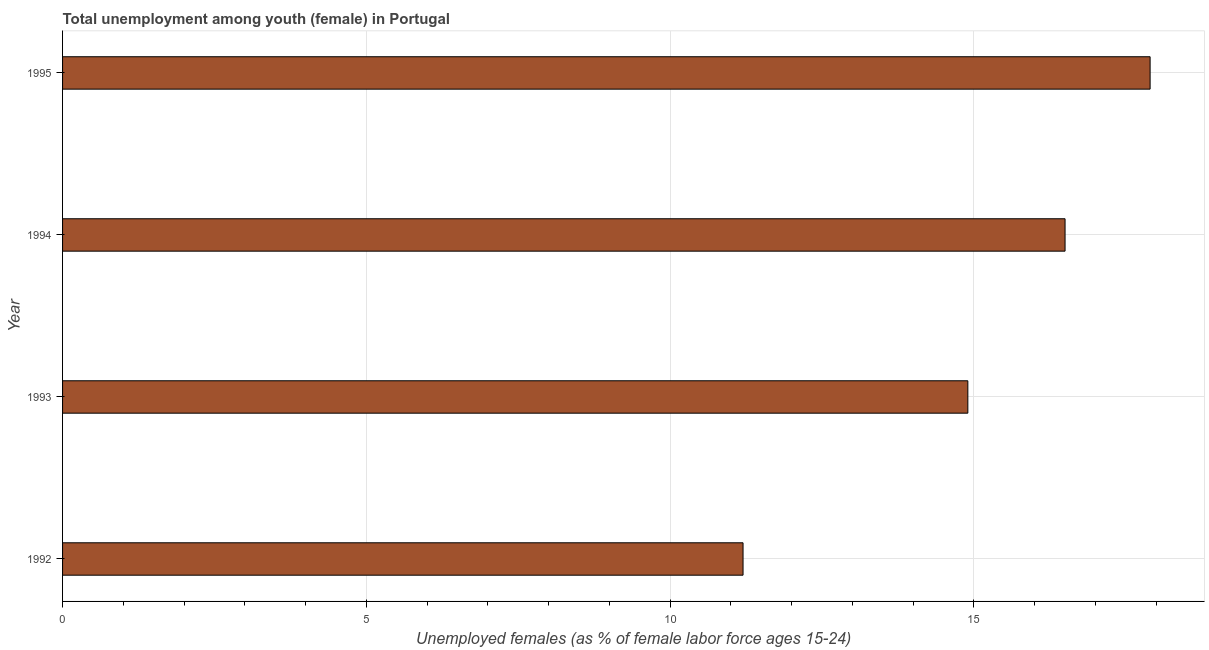Does the graph contain any zero values?
Your response must be concise. No. What is the title of the graph?
Make the answer very short. Total unemployment among youth (female) in Portugal. What is the label or title of the X-axis?
Give a very brief answer. Unemployed females (as % of female labor force ages 15-24). Across all years, what is the maximum unemployed female youth population?
Your answer should be very brief. 17.9. Across all years, what is the minimum unemployed female youth population?
Give a very brief answer. 11.2. What is the sum of the unemployed female youth population?
Keep it short and to the point. 60.5. What is the average unemployed female youth population per year?
Provide a succinct answer. 15.12. What is the median unemployed female youth population?
Offer a terse response. 15.7. In how many years, is the unemployed female youth population greater than 6 %?
Keep it short and to the point. 4. What is the ratio of the unemployed female youth population in 1992 to that in 1995?
Provide a short and direct response. 0.63. Is the unemployed female youth population in 1992 less than that in 1994?
Keep it short and to the point. Yes. Is the difference between the unemployed female youth population in 1992 and 1994 greater than the difference between any two years?
Provide a succinct answer. No. What is the difference between the highest and the second highest unemployed female youth population?
Give a very brief answer. 1.4. In how many years, is the unemployed female youth population greater than the average unemployed female youth population taken over all years?
Your response must be concise. 2. Are all the bars in the graph horizontal?
Your answer should be compact. Yes. What is the difference between two consecutive major ticks on the X-axis?
Ensure brevity in your answer.  5. Are the values on the major ticks of X-axis written in scientific E-notation?
Your response must be concise. No. What is the Unemployed females (as % of female labor force ages 15-24) in 1992?
Give a very brief answer. 11.2. What is the Unemployed females (as % of female labor force ages 15-24) of 1993?
Make the answer very short. 14.9. What is the Unemployed females (as % of female labor force ages 15-24) in 1994?
Provide a succinct answer. 16.5. What is the Unemployed females (as % of female labor force ages 15-24) in 1995?
Ensure brevity in your answer.  17.9. What is the difference between the Unemployed females (as % of female labor force ages 15-24) in 1992 and 1993?
Give a very brief answer. -3.7. What is the difference between the Unemployed females (as % of female labor force ages 15-24) in 1993 and 1994?
Make the answer very short. -1.6. What is the difference between the Unemployed females (as % of female labor force ages 15-24) in 1993 and 1995?
Provide a short and direct response. -3. What is the difference between the Unemployed females (as % of female labor force ages 15-24) in 1994 and 1995?
Keep it short and to the point. -1.4. What is the ratio of the Unemployed females (as % of female labor force ages 15-24) in 1992 to that in 1993?
Offer a very short reply. 0.75. What is the ratio of the Unemployed females (as % of female labor force ages 15-24) in 1992 to that in 1994?
Give a very brief answer. 0.68. What is the ratio of the Unemployed females (as % of female labor force ages 15-24) in 1992 to that in 1995?
Your answer should be compact. 0.63. What is the ratio of the Unemployed females (as % of female labor force ages 15-24) in 1993 to that in 1994?
Offer a very short reply. 0.9. What is the ratio of the Unemployed females (as % of female labor force ages 15-24) in 1993 to that in 1995?
Offer a terse response. 0.83. What is the ratio of the Unemployed females (as % of female labor force ages 15-24) in 1994 to that in 1995?
Make the answer very short. 0.92. 